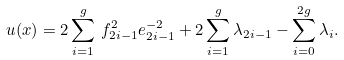<formula> <loc_0><loc_0><loc_500><loc_500>u ( x ) = 2 \sum _ { i = 1 } ^ { g } \, f _ { 2 i - 1 } ^ { 2 } e _ { 2 i - 1 } ^ { - 2 } + 2 \sum _ { i = 1 } ^ { g } \lambda _ { 2 i - 1 } - \sum _ { i = 0 } ^ { 2 g } \lambda _ { i } .</formula> 